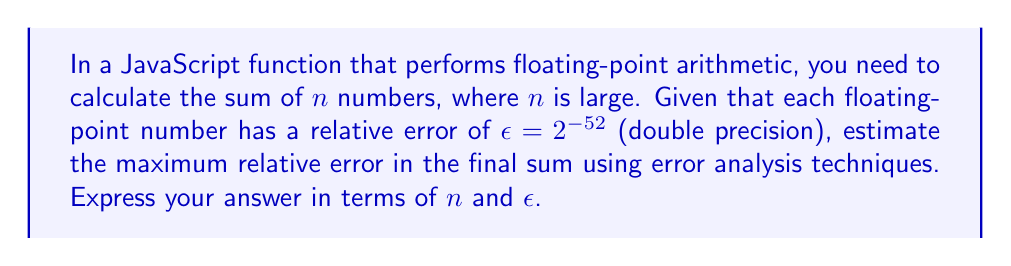Help me with this question. Let's approach this step-by-step:

1) In floating-point arithmetic, each number has a relative error of $\epsilon$. This means that if $x$ is the true value, the computed value $\tilde{x}$ satisfies:

   $$\tilde{x} = x(1 + \delta), \quad |\delta| \leq \epsilon$$

2) When we add two numbers, the errors can accumulate. If we add $\tilde{a}$ and $\tilde{b}$, the result is:

   $$\tilde{a} + \tilde{b} = (a + b)(1 + \eta), \quad |\eta| \leq 2\epsilon + O(\epsilon^2)$$

   We can ignore the higher-order term $O(\epsilon^2)$ as $\epsilon$ is very small.

3) Now, when we sum $n$ numbers, we're essentially performing $n-1$ additions. Each addition introduces a new error term.

4) In the worst-case scenario, these errors could all add up in the same direction. The maximum relative error after $n-1$ additions would be:

   $$E_{max} \approx (n-1) \cdot 2\epsilon$$

5) This is a conservative estimate that assumes the worst-case scenario where all errors add up. In practice, errors often partially cancel each other out, but for error analysis, we consider the worst case.

6) For large $n$, we can approximate this as:

   $$E_{max} \approx 2n\epsilon$$

7) In JavaScript, using double precision floating-point numbers (IEEE 754), $\epsilon = 2^{-52}$.
Answer: $2n\epsilon$ 